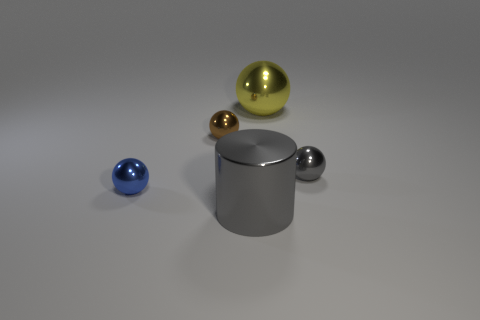Can you tell me what shapes are present in this image? Certainly! In the image, there is a variety of geometric shapes including a large gray cylinder, a big yellow sphere, a medium-sized brown sphere, and a smaller blue sphere. 